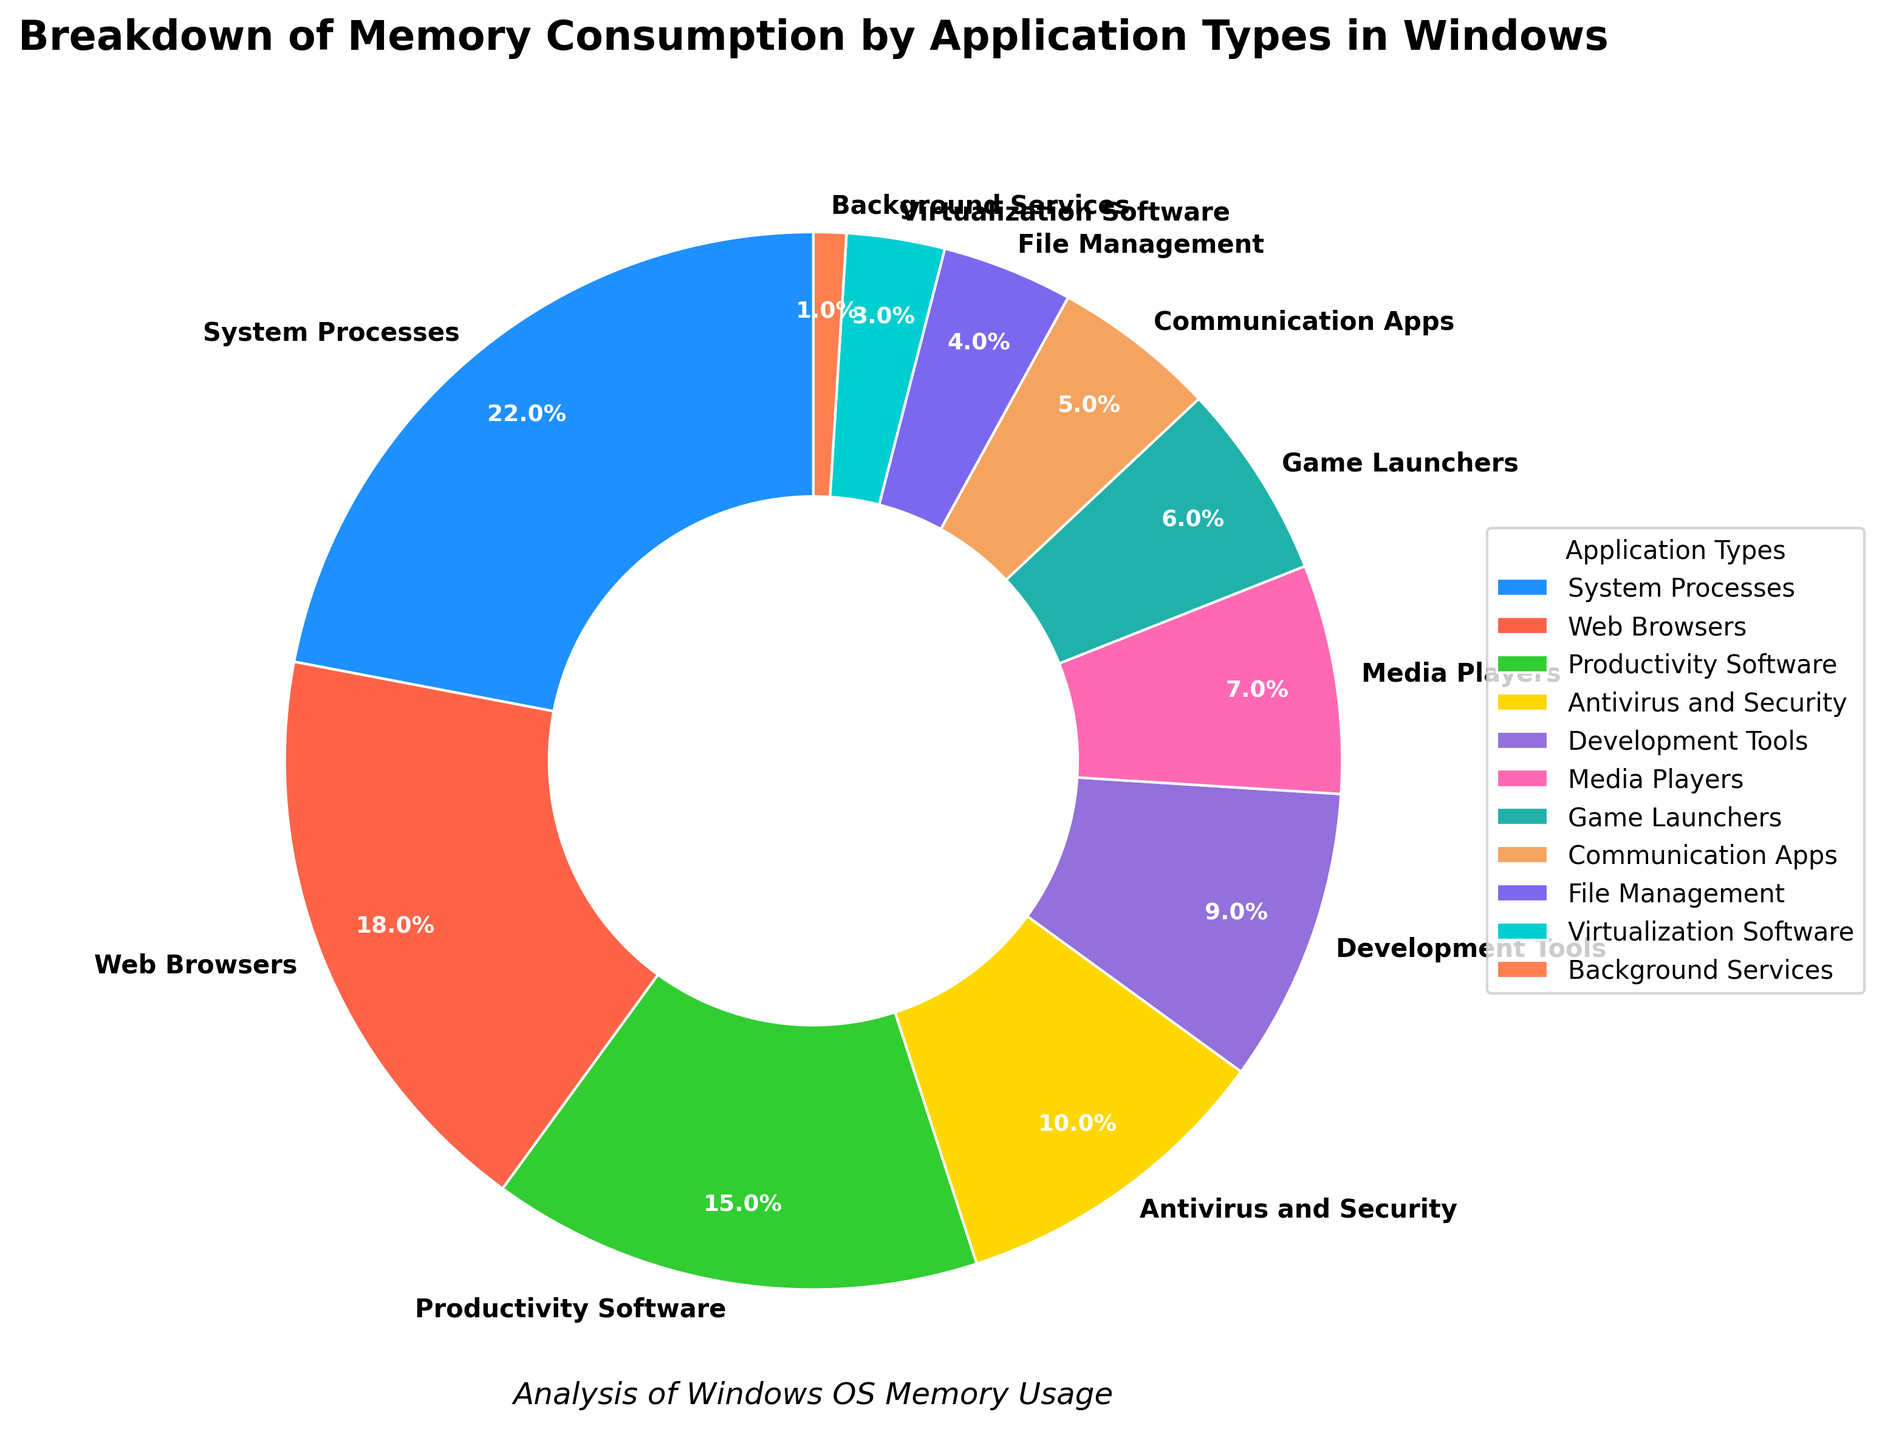Which application type consumes the highest percentage of memory? The pie chart shows that "System Processes" consumes the highest percentage of memory at 22%.
Answer: System Processes Which application type consumes less memory percentage: Development Tools or Communication Apps? The pie chart shows that "Development Tools" consumes 9% of memory, while "Communication Apps" consume 5%. Hence, "Communication Apps" consume less memory.
Answer: Communication Apps What is the combined memory consumption percentage for Media Players and Game Launchers? From the pie chart, "Media Players" consume 7% of memory and "Game Launchers" consume 6%. Adding these percentages gives 7% + 6% = 13%.
Answer: 13% Does Antivirus and Security consume more or less memory than Productivity Software? The pie chart displays that "Antivirus and Security" consumes 10% of memory and "Productivity Software" consumes 15%. Therefore, "Antivirus and Security" consumes less memory than "Productivity Software".
Answer: Less What is the percentage difference in memory usage between Web Browsers and Virtualization Software? The pie chart shows "Web Browsers" at 18% and "Virtualization Software" at 3%. The difference is 18% - 3% = 15%.
Answer: 15% Which application type is represented by a red segment in the pie chart? The pie chart uses different colors for different application types, and the segment colored red corresponds to "Web Browsers".
Answer: Web Browsers What is the memory consumption percentage for Background Services? The pie chart shows that "Background Services" consume 1% of memory.
Answer: 1% What is the total percentage of memory consumed by System Processes, Web Browsers, and Productivity Software combined? From the pie chart, "System Processes" consume 22%, "Web Browsers" consume 18%, and "Productivity Software" consume 15%. Adding these percentages gives 22% + 18% + 15% = 55%.
Answer: 55% Identify the two least memory-consuming application types and their combined usage. The pie chart shows that "Background Services" consume 1% and "Virtualization Software" consumes 3%, making them the two least memory-consuming application types. Their combined usage is 1% + 3% = 4%.
Answer: Background Services and Virtualization Software, 4% What is the percentage of memory used by applications other than System Processes and Web Browsers? The total memory consumption is 100%. "System Processes" and "Web Browsers" consume 22% and 18% respectively. Subtracting these from 100%, we get 100% - 22% - 18% = 60%.
Answer: 60% 